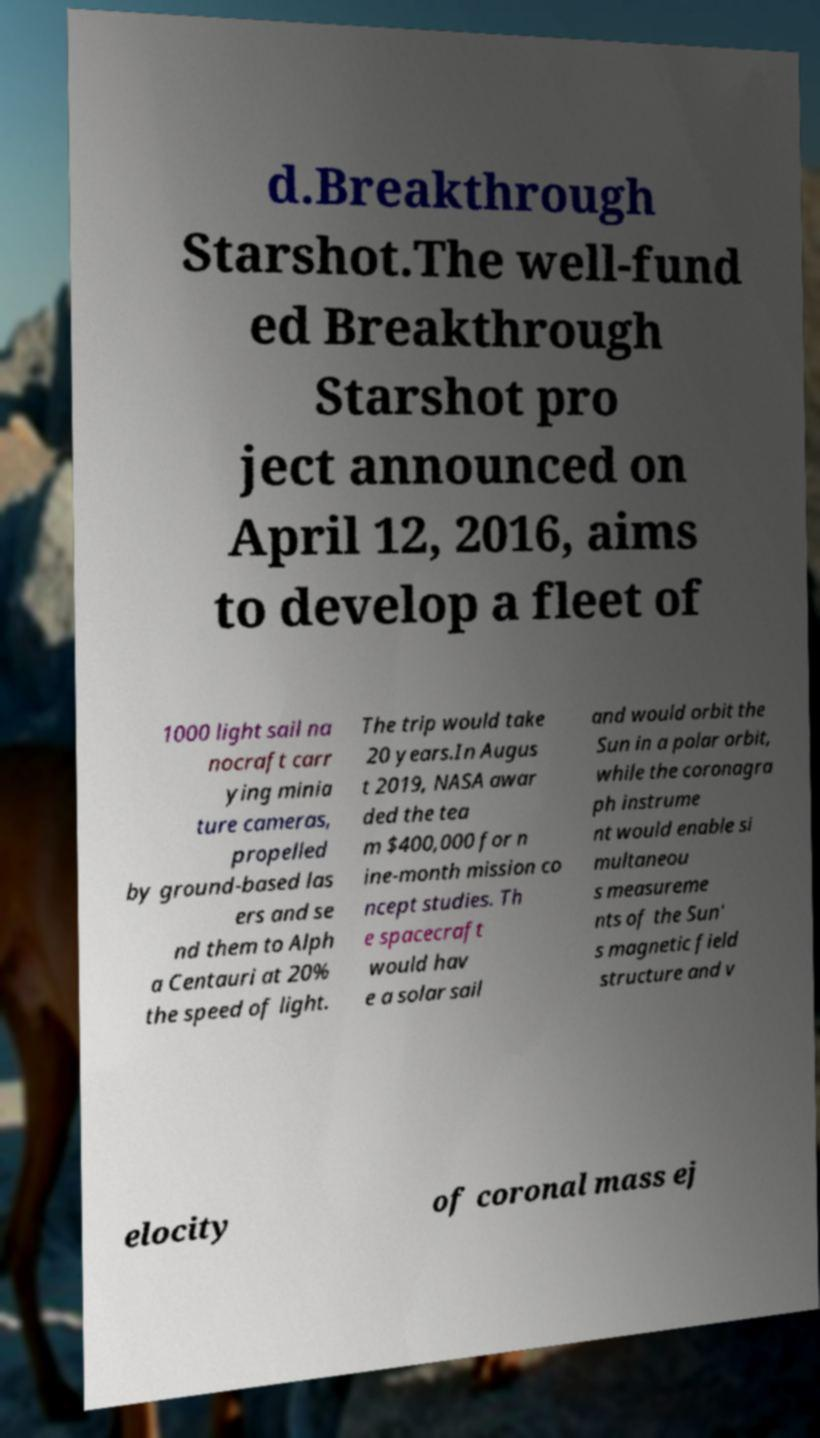Can you read and provide the text displayed in the image?This photo seems to have some interesting text. Can you extract and type it out for me? d.Breakthrough Starshot.The well-fund ed Breakthrough Starshot pro ject announced on April 12, 2016, aims to develop a fleet of 1000 light sail na nocraft carr ying minia ture cameras, propelled by ground-based las ers and se nd them to Alph a Centauri at 20% the speed of light. The trip would take 20 years.In Augus t 2019, NASA awar ded the tea m $400,000 for n ine-month mission co ncept studies. Th e spacecraft would hav e a solar sail and would orbit the Sun in a polar orbit, while the coronagra ph instrume nt would enable si multaneou s measureme nts of the Sun' s magnetic field structure and v elocity of coronal mass ej 